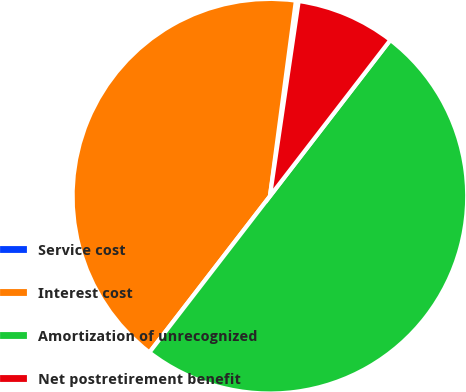<chart> <loc_0><loc_0><loc_500><loc_500><pie_chart><fcel>Service cost<fcel>Interest cost<fcel>Amortization of unrecognized<fcel>Net postretirement benefit<nl><fcel>0.23%<fcel>41.64%<fcel>50.0%<fcel>8.12%<nl></chart> 